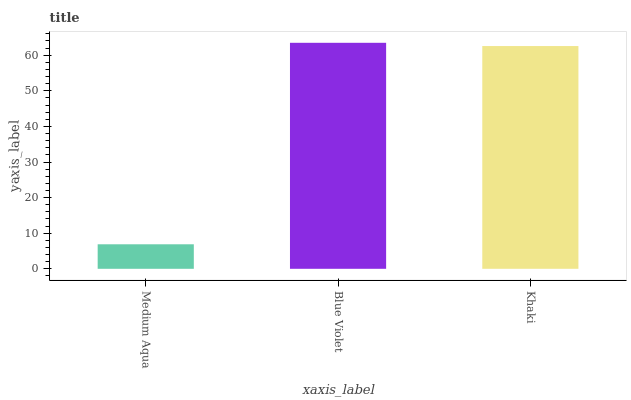Is Medium Aqua the minimum?
Answer yes or no. Yes. Is Blue Violet the maximum?
Answer yes or no. Yes. Is Khaki the minimum?
Answer yes or no. No. Is Khaki the maximum?
Answer yes or no. No. Is Blue Violet greater than Khaki?
Answer yes or no. Yes. Is Khaki less than Blue Violet?
Answer yes or no. Yes. Is Khaki greater than Blue Violet?
Answer yes or no. No. Is Blue Violet less than Khaki?
Answer yes or no. No. Is Khaki the high median?
Answer yes or no. Yes. Is Khaki the low median?
Answer yes or no. Yes. Is Blue Violet the high median?
Answer yes or no. No. Is Blue Violet the low median?
Answer yes or no. No. 